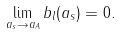Convert formula to latex. <formula><loc_0><loc_0><loc_500><loc_500>\lim _ { a _ { s } \rightarrow a _ { A } } b _ { l } ( a _ { s } ) = 0 .</formula> 